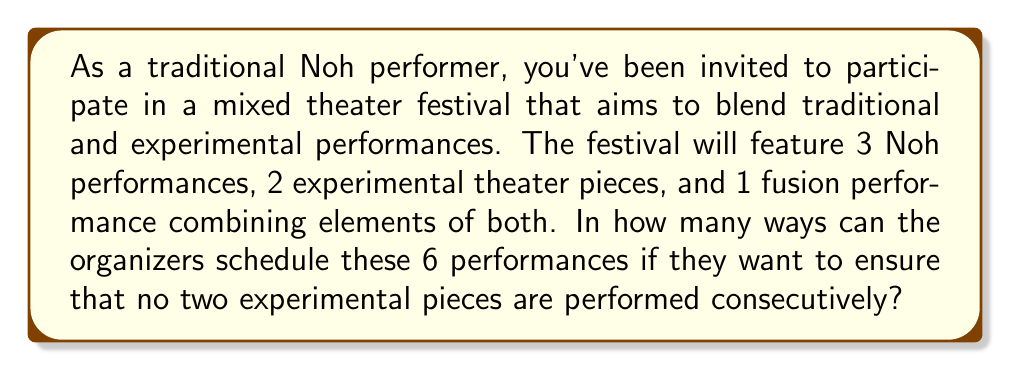Show me your answer to this math problem. Let's approach this step-by-step:

1) First, we need to consider the total number of performances: 
   3 Noh (N), 2 Experimental (E), and 1 Fusion (F). Total: 6 performances.

2) The key constraint is that no two experimental pieces can be adjacent. This means we need to separate the Es with other performances.

3) We can think of this as arranging 4 slots: 3N, 1F, and 2E. The 2E must be placed in non-adjacent positions.

4) Let's represent the non-E performances as _. So we have 4 _ and need to choose 2 positions for E.

5) We can represent this as: _ _ _ _ _
   Where we need to choose 2 of the 5 gaps (including ends) to place our Es.

6) This is a combination problem. We're choosing 2 positions out of 5 possible positions. This can be represented as $\binom{5}{2}$.

7) $\binom{5}{2} = \frac{5!}{2!(5-2)!} = \frac{5 \cdot 4}{2 \cdot 1} = 10$

8) Now, for each of these 10 arrangements of Es, we need to arrange the 3N and 1F in the remaining 4 positions.

9) This is a permutation of 4 items, where 3 are identical (N) and 1 is distinct (F).
   This can be calculated as: $\frac{4!}{3!} = 4$

10) By the multiplication principle, the total number of possible schedules is:

    $10 \cdot 4 = 40$
Answer: 40 possible schedules 